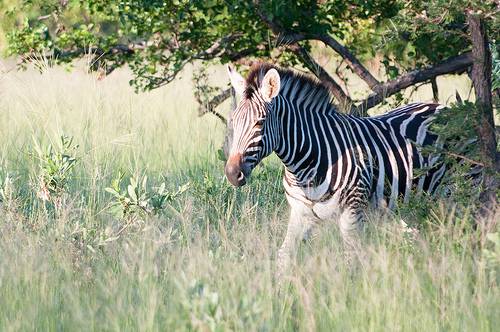Please provide the bounding box coordinate of the region this sentence describes: The tree is full of green leaves. The bounding box coordinates for the region describing 'the tree is full of green leaves' are [0.01, 0.18, 1.0, 0.29]. This area likely captures the green canopy of leaves mentioned. 